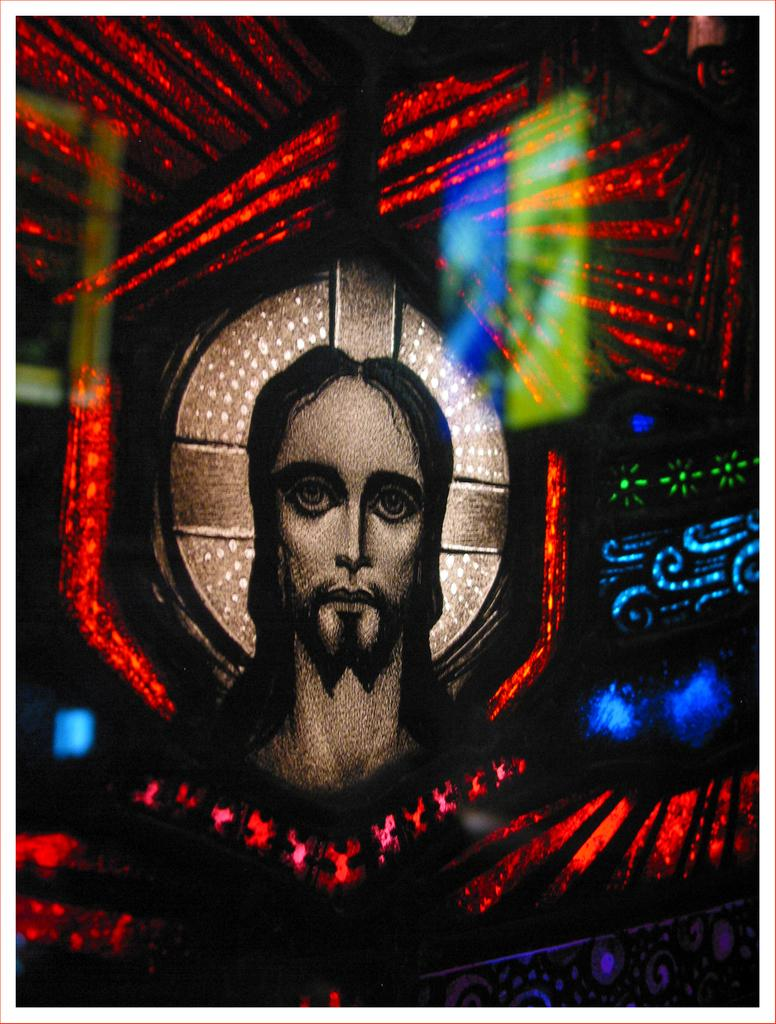What is depicted in the image? There is a picture of a man in the image. How is the picture of the man presented? The picture of the man looks like a painting. What other elements are present in the image? There are colorful lights in the image. What type of discovery is being celebrated in the image? There is no discovery being celebrated in the image; it features a picture of a man and colorful lights. 